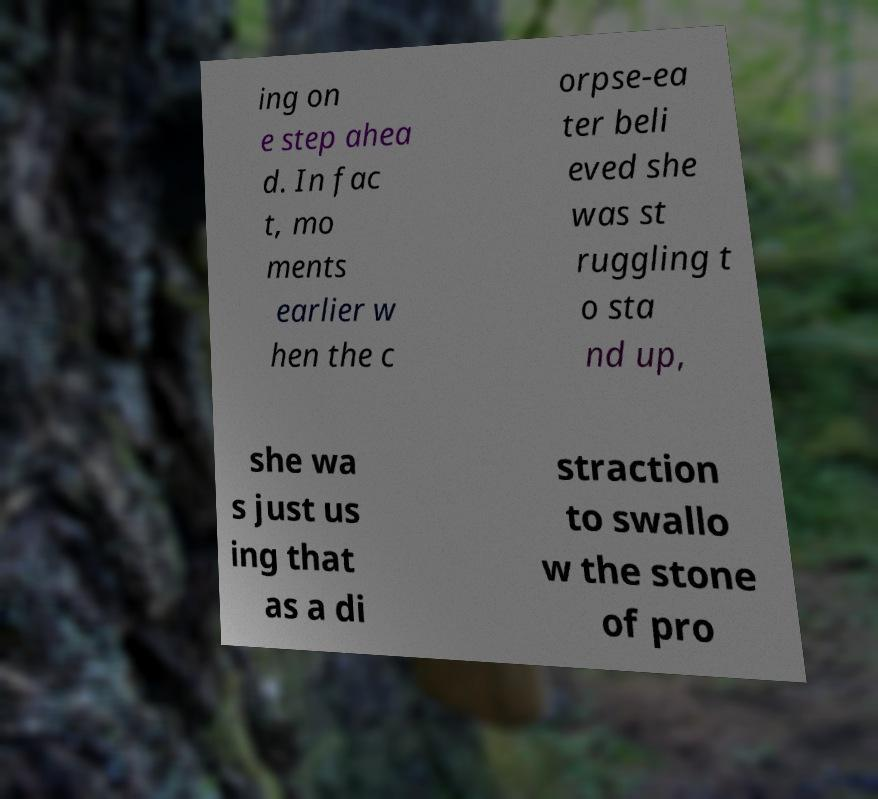Can you accurately transcribe the text from the provided image for me? ing on e step ahea d. In fac t, mo ments earlier w hen the c orpse-ea ter beli eved she was st ruggling t o sta nd up, she wa s just us ing that as a di straction to swallo w the stone of pro 